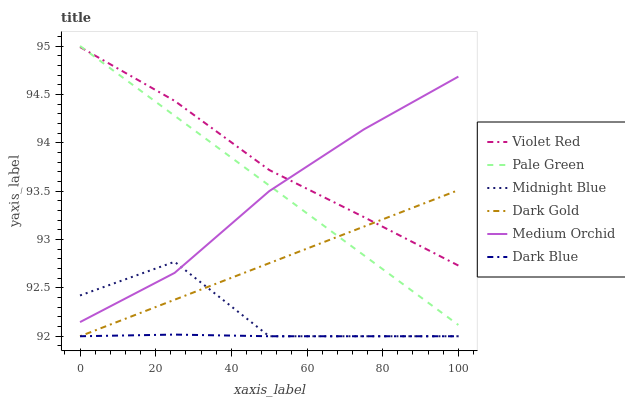Does Dark Blue have the minimum area under the curve?
Answer yes or no. Yes. Does Violet Red have the maximum area under the curve?
Answer yes or no. Yes. Does Midnight Blue have the minimum area under the curve?
Answer yes or no. No. Does Midnight Blue have the maximum area under the curve?
Answer yes or no. No. Is Dark Gold the smoothest?
Answer yes or no. Yes. Is Midnight Blue the roughest?
Answer yes or no. Yes. Is Midnight Blue the smoothest?
Answer yes or no. No. Is Dark Gold the roughest?
Answer yes or no. No. Does Midnight Blue have the lowest value?
Answer yes or no. Yes. Does Medium Orchid have the lowest value?
Answer yes or no. No. Does Pale Green have the highest value?
Answer yes or no. Yes. Does Midnight Blue have the highest value?
Answer yes or no. No. Is Dark Blue less than Pale Green?
Answer yes or no. Yes. Is Violet Red greater than Midnight Blue?
Answer yes or no. Yes. Does Midnight Blue intersect Dark Blue?
Answer yes or no. Yes. Is Midnight Blue less than Dark Blue?
Answer yes or no. No. Is Midnight Blue greater than Dark Blue?
Answer yes or no. No. Does Dark Blue intersect Pale Green?
Answer yes or no. No. 